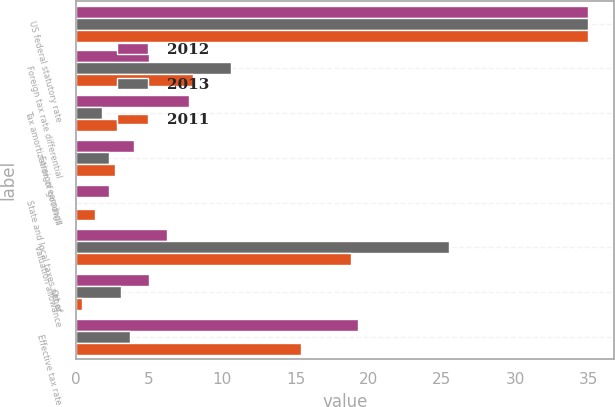Convert chart. <chart><loc_0><loc_0><loc_500><loc_500><stacked_bar_chart><ecel><fcel>US federal statutory rate<fcel>Foreign tax rate differential<fcel>Tax amortization of goodwill<fcel>Foreign earnings<fcel>State and local taxes net of<fcel>Valuation allowance<fcel>Other<fcel>Effective tax rate<nl><fcel>2012<fcel>35<fcel>5<fcel>7.7<fcel>4<fcel>2.3<fcel>6.2<fcel>5<fcel>19.3<nl><fcel>2013<fcel>35<fcel>10.6<fcel>1.8<fcel>2.3<fcel>0<fcel>25.5<fcel>3.1<fcel>3.7<nl><fcel>2011<fcel>35<fcel>8<fcel>2.8<fcel>2.7<fcel>1.3<fcel>18.8<fcel>0.4<fcel>15.4<nl></chart> 